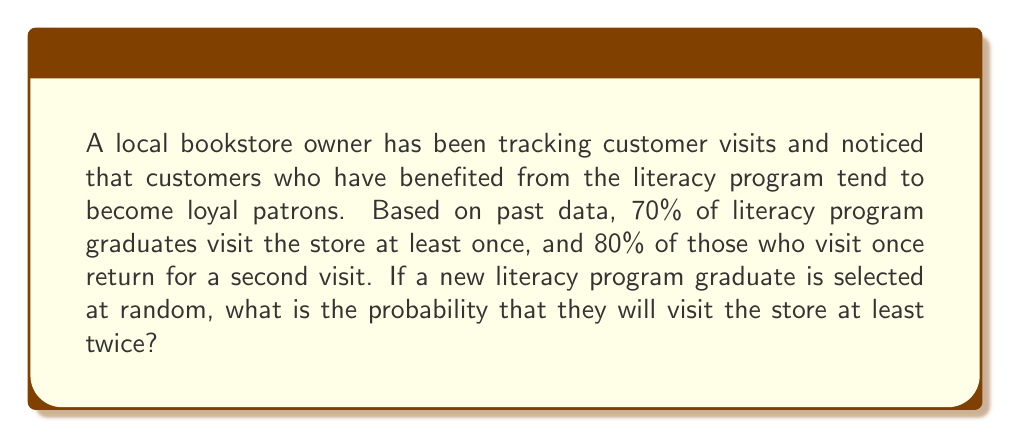Solve this math problem. To solve this problem, we'll use Bayesian probability concepts. Let's break it down step by step:

1. Define the events:
   A: The customer visits the store at least once
   B: The customer returns for a second visit

2. Given probabilities:
   P(A) = 0.70 (70% of literacy program graduates visit at least once)
   P(B|A) = 0.80 (80% of those who visit once return for a second visit)

3. We want to find P(A and B), which is the probability that a customer both visits once and returns for a second visit.

4. Using the multiplication rule of probability:
   P(A and B) = P(A) × P(B|A)

5. Substituting the values:
   P(A and B) = 0.70 × 0.80 = 0.56

Therefore, the probability that a new literacy program graduate will visit the store at least twice is 0.56 or 56%.

This can be represented in LaTeX as:

$$P(A \text{ and } B) = P(A) \times P(B|A) = 0.70 \times 0.80 = 0.56$$
Answer: The probability that a new literacy program graduate will visit the store at least twice is $0.56$ or $56\%$. 